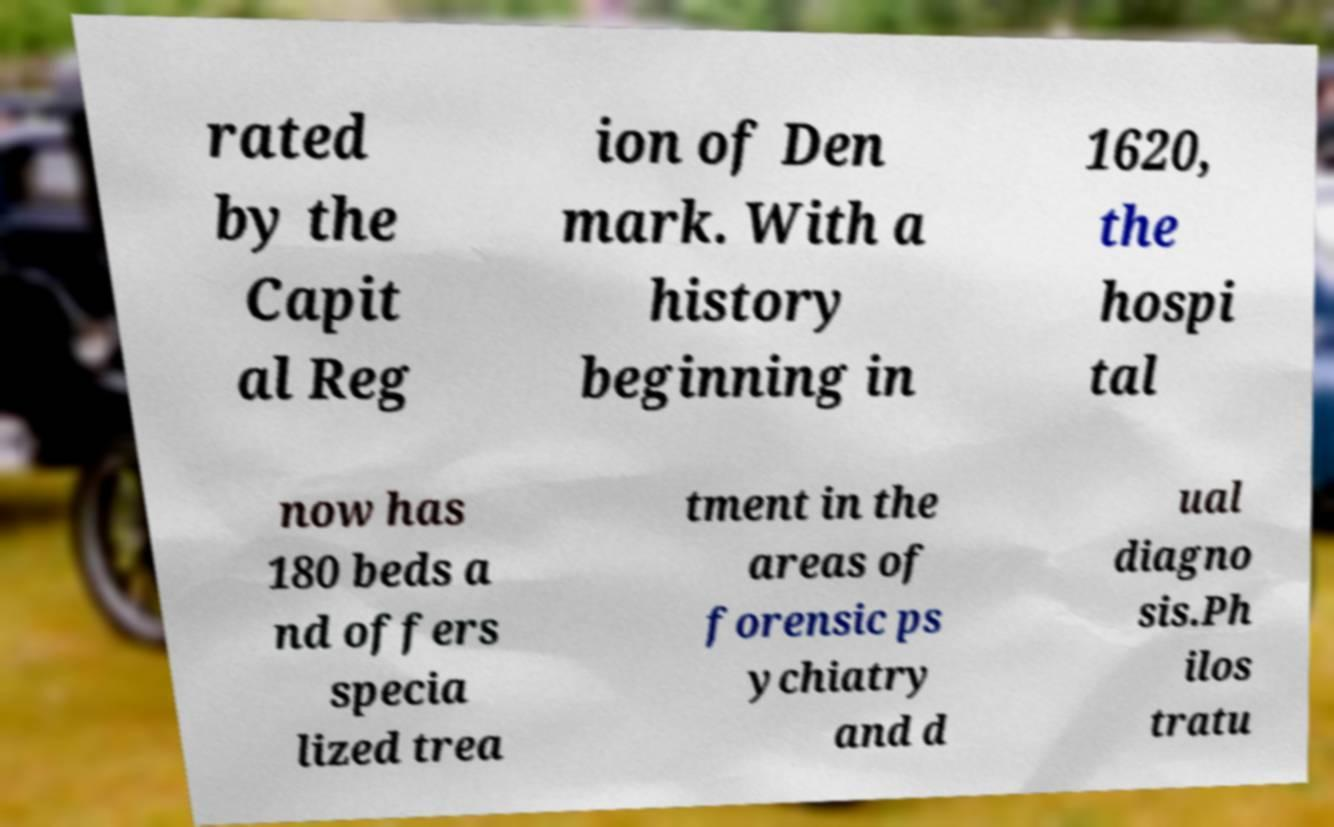Could you assist in decoding the text presented in this image and type it out clearly? rated by the Capit al Reg ion of Den mark. With a history beginning in 1620, the hospi tal now has 180 beds a nd offers specia lized trea tment in the areas of forensic ps ychiatry and d ual diagno sis.Ph ilos tratu 